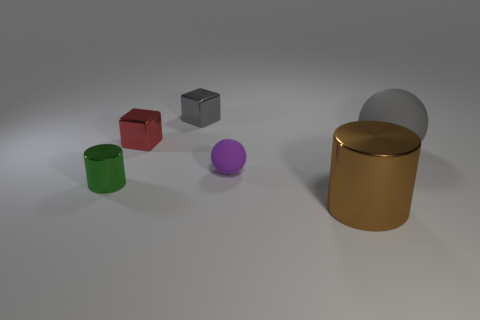Are there any big gray balls?
Offer a very short reply. Yes. Is the size of the brown shiny cylinder the same as the rubber thing to the left of the big brown metal thing?
Give a very brief answer. No. There is a tiny object that is on the right side of the gray metallic block; are there any metal objects that are behind it?
Offer a very short reply. Yes. There is a thing that is both right of the purple rubber thing and in front of the big gray matte sphere; what material is it?
Offer a terse response. Metal. The rubber ball that is in front of the big thing that is behind the metallic cylinder on the right side of the green object is what color?
Ensure brevity in your answer.  Purple. What is the color of the cylinder that is the same size as the purple rubber object?
Your answer should be compact. Green. There is a big sphere; is it the same color as the block that is to the right of the red metallic cube?
Your answer should be compact. Yes. There is a small red thing that is behind the metal object in front of the tiny cylinder; what is its material?
Give a very brief answer. Metal. What number of shiny things are both in front of the red thing and behind the big brown metal cylinder?
Ensure brevity in your answer.  1. How many other things are there of the same size as the gray cube?
Ensure brevity in your answer.  3. 